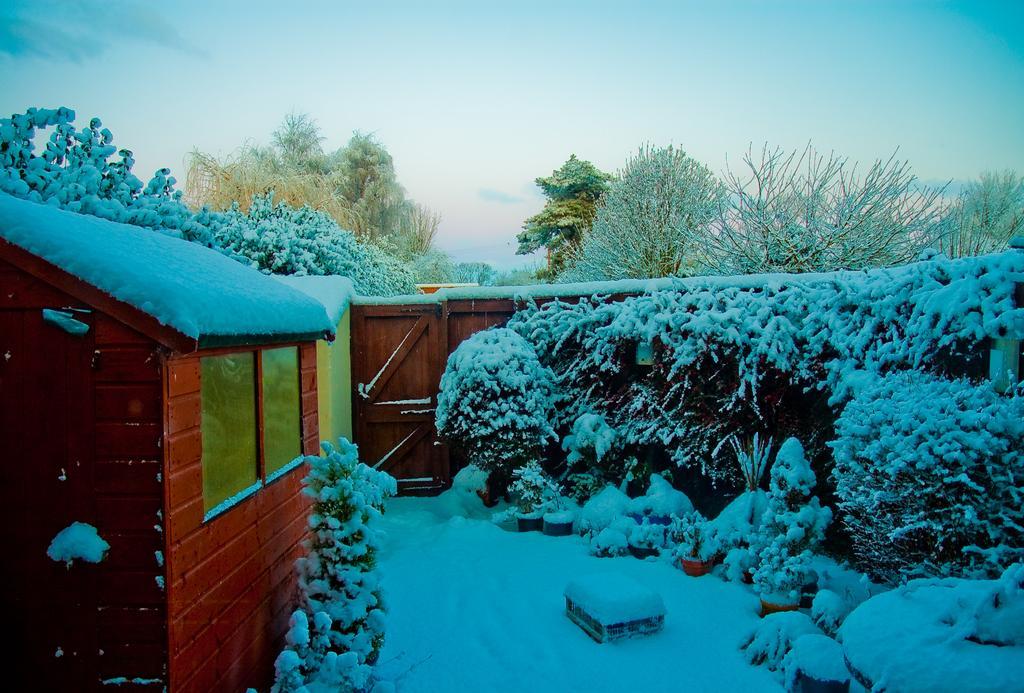In one or two sentences, can you explain what this image depicts? In this image we can see a sky. There are many trees and plants in the image. There is a snow in the image. There's a house in the image. There is a gate and the fencing in the image. There is an object on the ground. 